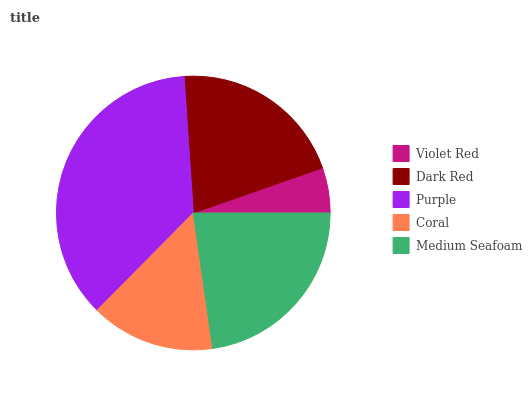Is Violet Red the minimum?
Answer yes or no. Yes. Is Purple the maximum?
Answer yes or no. Yes. Is Dark Red the minimum?
Answer yes or no. No. Is Dark Red the maximum?
Answer yes or no. No. Is Dark Red greater than Violet Red?
Answer yes or no. Yes. Is Violet Red less than Dark Red?
Answer yes or no. Yes. Is Violet Red greater than Dark Red?
Answer yes or no. No. Is Dark Red less than Violet Red?
Answer yes or no. No. Is Dark Red the high median?
Answer yes or no. Yes. Is Dark Red the low median?
Answer yes or no. Yes. Is Coral the high median?
Answer yes or no. No. Is Medium Seafoam the low median?
Answer yes or no. No. 